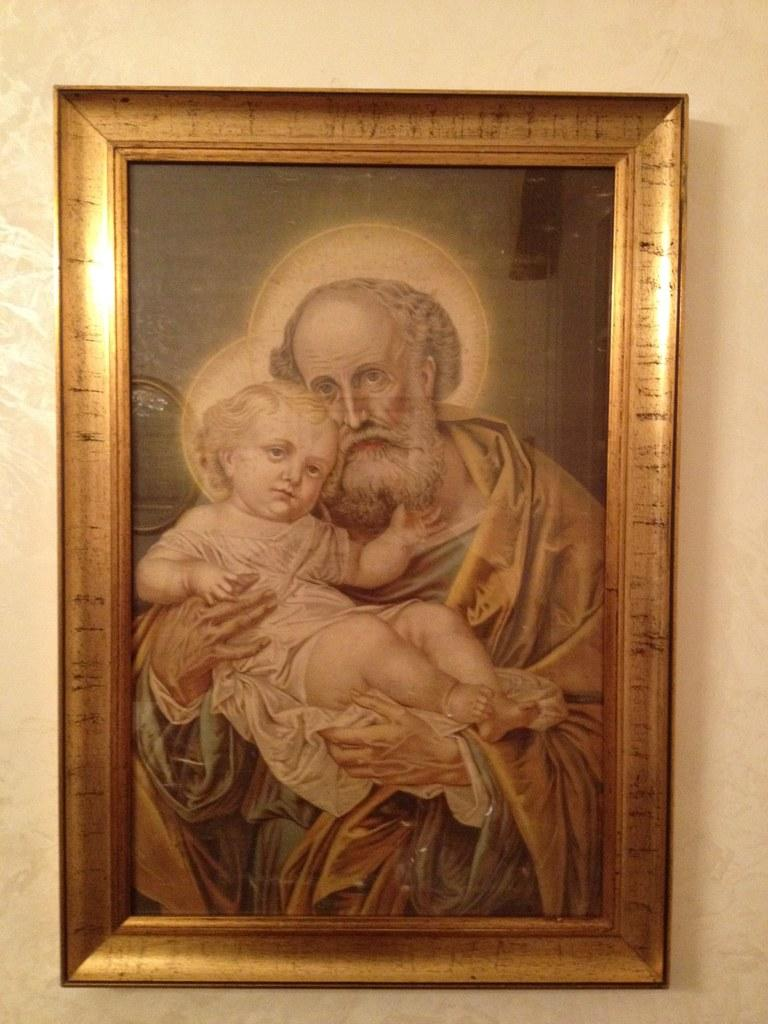What is hanging on the wall in the image? There is a photo-frame on the wall in the image. What is depicted in the photo-frame? The photo-frame contains a picture of an old man holding a baby. Where is the jar located in the image? There is no jar present in the image. 